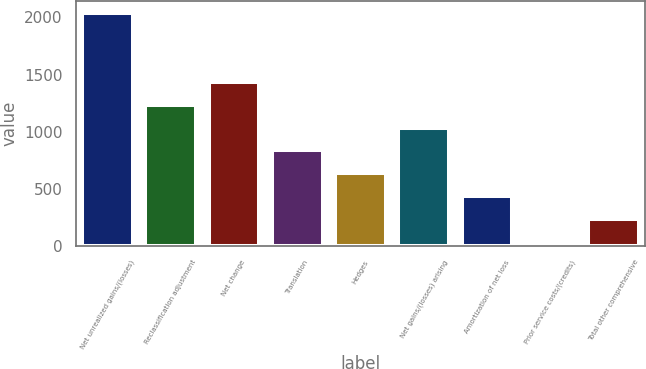Convert chart to OTSL. <chart><loc_0><loc_0><loc_500><loc_500><bar_chart><fcel>Net unrealized gains/(losses)<fcel>Reclassification adjustment<fcel>Net change<fcel>Translation<fcel>Hedges<fcel>Net gains/(losses) arising<fcel>Amortization of net loss<fcel>Prior service costs/(credits)<fcel>Total other comprehensive<nl><fcel>2039<fcel>1236.2<fcel>1436.9<fcel>834.8<fcel>634.1<fcel>1035.5<fcel>433.4<fcel>32<fcel>232.7<nl></chart> 